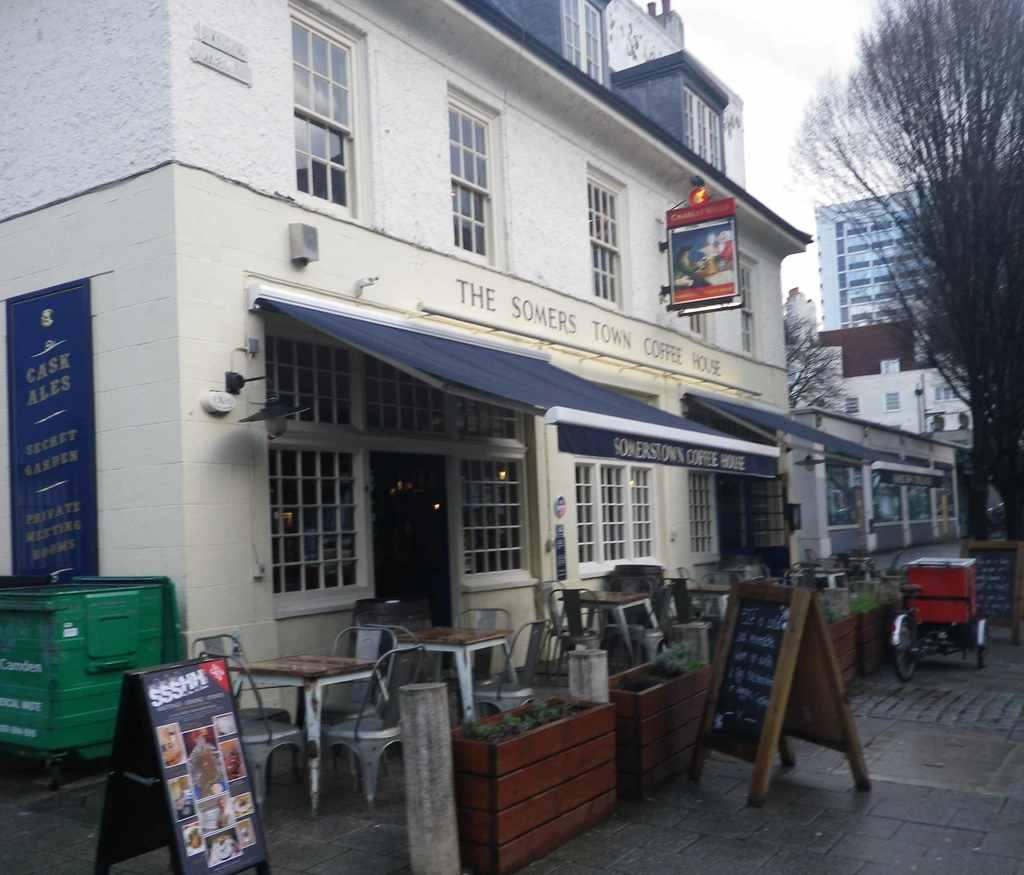What type of structure is visible in the image? There is a building in the image. What is the setting of the image? There is a street in the image. What is the purpose of the blackboard in the image? The blackboard is likely used for writing or displaying information. What type of furniture is present in the image? Chairs and tables are present in the image. What is the location of the tree in the image? There is a tree in front of the building. What can be seen above the building in the image? The sky is visible above the building. What type of voice can be heard coming from the school in the image? There is no school present in the image, so it is not possible to determine what type of voice might be heard. 